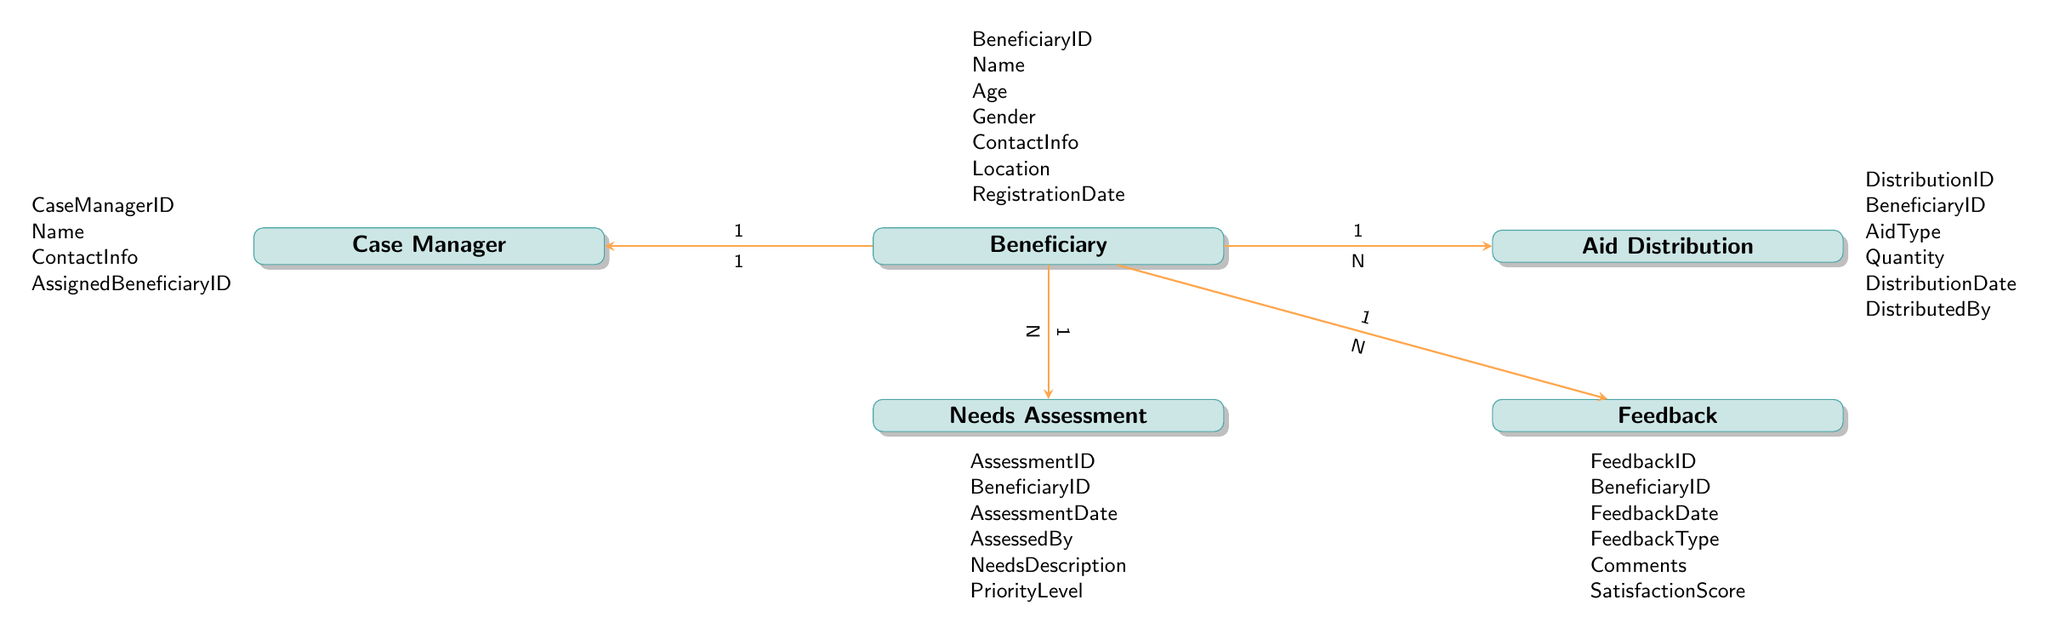What entity represents the person receiving aid? The diagram identifies the entity labeled "Beneficiary" which explicitly defines individuals who receive help through various aid programs.
Answer: Beneficiary How many attributes does the Aid Distribution entity have? The Aid Distribution entity is shown to have six attributes in the diagram: DistributionID, BeneficiaryID, AidType, Quantity, DistributionDate, and DistributedBy, so you simply count them.
Answer: 6 What is the relationship type between Beneficiary and Needs Assessment? Looking at the arrows between the Beneficiary and Needs Assessment entities in the diagram, it shows a one-to-many relationship, signifying one beneficiary can have multiple needs assessments.
Answer: one-to-many What is the priority to which a needs assessment can be assigned? The Needs Assessment entity includes the attribute "PriorityLevel” which indicates how urgent or important the needs are for each beneficiary.
Answer: PriorityLevel How many entities are there in total in this diagram? By counting the number of distinct entities listed in the diagram, you find there are five entities: Beneficiary, Needs Assessment, Aid Distribution, Feedback, and Case Manager.
Answer: 5 What is the relationship between Beneficiary and Case Manager? The diagram depicts a one-to-one relationship between Beneficiary and Case Manager, indicating that each beneficiary is assigned one specific case manager.
Answer: one-to-one Which entity collects feedback from beneficiaries? The Feedback entity is specifically designed to gather responses and evaluations from beneficiaries about the aid they received, as shown in the diagram.
Answer: Feedback What type of data does the Feedback entity track regarding satisfaction? In reviewing the attributes of the Feedback entity, "SatisfactionScore" is the specific data attribute that indicates how satisfied the beneficiary is with the aid received.
Answer: SatisfactionScore Which entity assesses the needs of the beneficiaries? The Needs Assessment entity is dedicated to evaluating and determining what assistance beneficiaries require, as indicated in the diagram’s labeling of entities.
Answer: Needs Assessment 